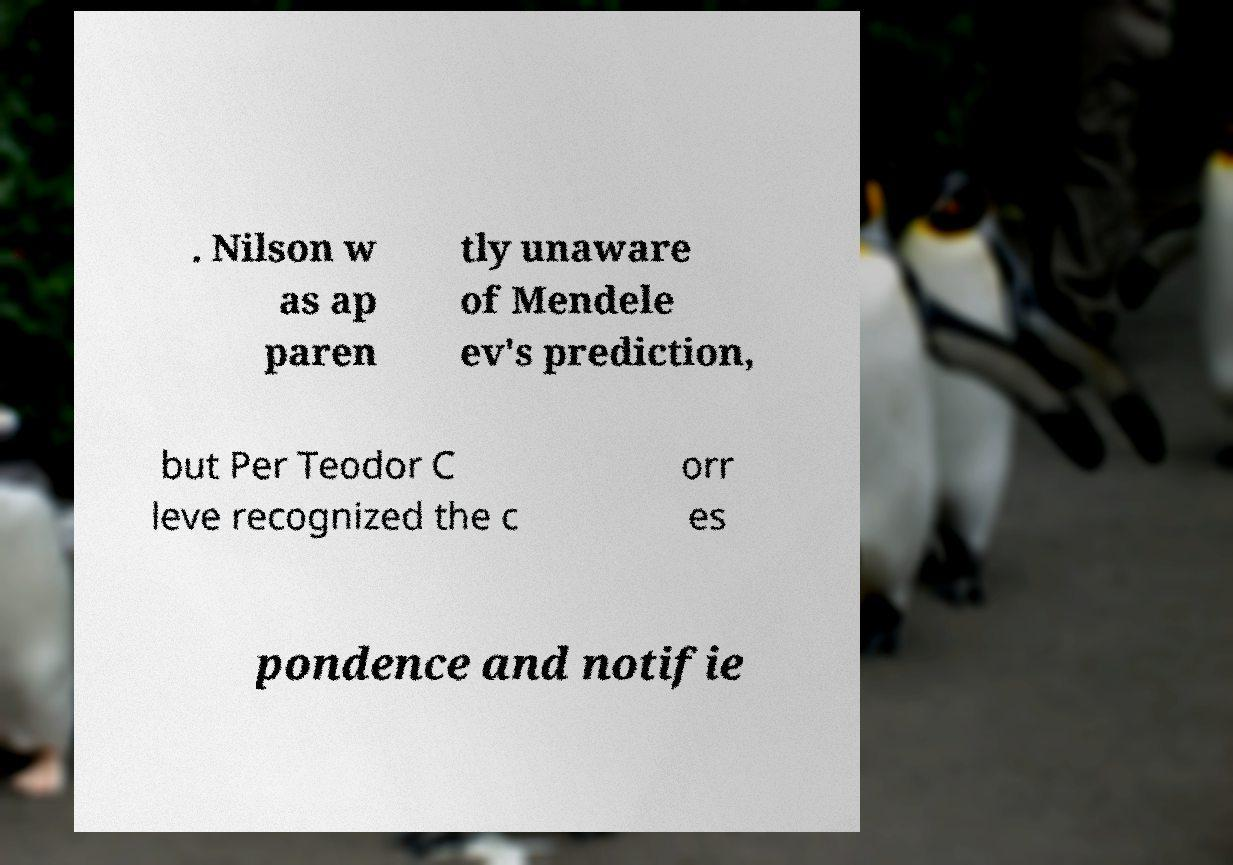Can you accurately transcribe the text from the provided image for me? . Nilson w as ap paren tly unaware of Mendele ev's prediction, but Per Teodor C leve recognized the c orr es pondence and notifie 